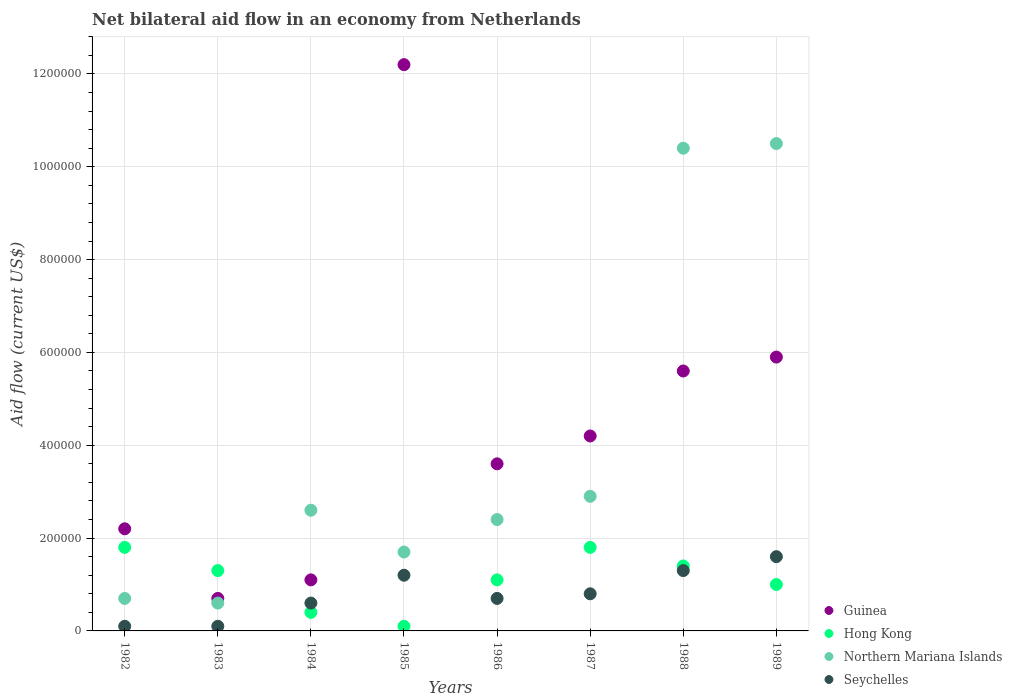Is the number of dotlines equal to the number of legend labels?
Your answer should be compact. Yes. What is the net bilateral aid flow in Northern Mariana Islands in 1987?
Make the answer very short. 2.90e+05. In which year was the net bilateral aid flow in Northern Mariana Islands minimum?
Your answer should be compact. 1983. What is the total net bilateral aid flow in Seychelles in the graph?
Offer a terse response. 6.40e+05. What is the difference between the net bilateral aid flow in Hong Kong in 1983 and that in 1987?
Your answer should be very brief. -5.00e+04. What is the average net bilateral aid flow in Northern Mariana Islands per year?
Offer a terse response. 3.98e+05. In the year 1985, what is the difference between the net bilateral aid flow in Hong Kong and net bilateral aid flow in Northern Mariana Islands?
Offer a terse response. -1.60e+05. What is the ratio of the net bilateral aid flow in Guinea in 1984 to that in 1985?
Keep it short and to the point. 0.09. Is the net bilateral aid flow in Guinea in 1982 less than that in 1983?
Your answer should be compact. No. Is the difference between the net bilateral aid flow in Hong Kong in 1982 and 1984 greater than the difference between the net bilateral aid flow in Northern Mariana Islands in 1982 and 1984?
Give a very brief answer. Yes. What is the difference between the highest and the second highest net bilateral aid flow in Hong Kong?
Offer a very short reply. 0. What is the difference between the highest and the lowest net bilateral aid flow in Guinea?
Provide a short and direct response. 1.15e+06. Is it the case that in every year, the sum of the net bilateral aid flow in Seychelles and net bilateral aid flow in Northern Mariana Islands  is greater than the sum of net bilateral aid flow in Guinea and net bilateral aid flow in Hong Kong?
Provide a short and direct response. No. Is it the case that in every year, the sum of the net bilateral aid flow in Hong Kong and net bilateral aid flow in Seychelles  is greater than the net bilateral aid flow in Guinea?
Provide a short and direct response. No. How many years are there in the graph?
Keep it short and to the point. 8. Are the values on the major ticks of Y-axis written in scientific E-notation?
Keep it short and to the point. No. Does the graph contain any zero values?
Offer a terse response. No. Where does the legend appear in the graph?
Give a very brief answer. Bottom right. How many legend labels are there?
Offer a very short reply. 4. How are the legend labels stacked?
Your response must be concise. Vertical. What is the title of the graph?
Give a very brief answer. Net bilateral aid flow in an economy from Netherlands. Does "New Caledonia" appear as one of the legend labels in the graph?
Offer a terse response. No. What is the label or title of the X-axis?
Ensure brevity in your answer.  Years. What is the Aid flow (current US$) of Guinea in 1982?
Offer a terse response. 2.20e+05. What is the Aid flow (current US$) in Northern Mariana Islands in 1982?
Offer a very short reply. 7.00e+04. What is the Aid flow (current US$) of Seychelles in 1982?
Keep it short and to the point. 10000. What is the Aid flow (current US$) in Guinea in 1983?
Your answer should be very brief. 7.00e+04. What is the Aid flow (current US$) of Guinea in 1984?
Make the answer very short. 1.10e+05. What is the Aid flow (current US$) in Hong Kong in 1984?
Offer a terse response. 4.00e+04. What is the Aid flow (current US$) in Seychelles in 1984?
Keep it short and to the point. 6.00e+04. What is the Aid flow (current US$) in Guinea in 1985?
Ensure brevity in your answer.  1.22e+06. What is the Aid flow (current US$) of Northern Mariana Islands in 1985?
Your answer should be compact. 1.70e+05. What is the Aid flow (current US$) in Guinea in 1986?
Offer a terse response. 3.60e+05. What is the Aid flow (current US$) of Hong Kong in 1986?
Keep it short and to the point. 1.10e+05. What is the Aid flow (current US$) in Northern Mariana Islands in 1986?
Your answer should be very brief. 2.40e+05. What is the Aid flow (current US$) in Hong Kong in 1987?
Your answer should be compact. 1.80e+05. What is the Aid flow (current US$) of Guinea in 1988?
Your response must be concise. 5.60e+05. What is the Aid flow (current US$) of Northern Mariana Islands in 1988?
Provide a succinct answer. 1.04e+06. What is the Aid flow (current US$) of Seychelles in 1988?
Your answer should be compact. 1.30e+05. What is the Aid flow (current US$) of Guinea in 1989?
Provide a succinct answer. 5.90e+05. What is the Aid flow (current US$) in Northern Mariana Islands in 1989?
Give a very brief answer. 1.05e+06. Across all years, what is the maximum Aid flow (current US$) in Guinea?
Your response must be concise. 1.22e+06. Across all years, what is the maximum Aid flow (current US$) in Northern Mariana Islands?
Your answer should be compact. 1.05e+06. Across all years, what is the maximum Aid flow (current US$) of Seychelles?
Your answer should be compact. 1.60e+05. Across all years, what is the minimum Aid flow (current US$) of Guinea?
Your answer should be very brief. 7.00e+04. Across all years, what is the minimum Aid flow (current US$) of Hong Kong?
Provide a succinct answer. 10000. Across all years, what is the minimum Aid flow (current US$) of Northern Mariana Islands?
Keep it short and to the point. 6.00e+04. What is the total Aid flow (current US$) in Guinea in the graph?
Offer a very short reply. 3.55e+06. What is the total Aid flow (current US$) in Hong Kong in the graph?
Keep it short and to the point. 8.90e+05. What is the total Aid flow (current US$) of Northern Mariana Islands in the graph?
Your answer should be compact. 3.18e+06. What is the total Aid flow (current US$) in Seychelles in the graph?
Your response must be concise. 6.40e+05. What is the difference between the Aid flow (current US$) of Hong Kong in 1982 and that in 1983?
Offer a very short reply. 5.00e+04. What is the difference between the Aid flow (current US$) in Seychelles in 1982 and that in 1983?
Keep it short and to the point. 0. What is the difference between the Aid flow (current US$) in Guinea in 1982 and that in 1984?
Your response must be concise. 1.10e+05. What is the difference between the Aid flow (current US$) of Hong Kong in 1982 and that in 1984?
Your answer should be compact. 1.40e+05. What is the difference between the Aid flow (current US$) in Seychelles in 1982 and that in 1984?
Provide a succinct answer. -5.00e+04. What is the difference between the Aid flow (current US$) in Northern Mariana Islands in 1982 and that in 1985?
Make the answer very short. -1.00e+05. What is the difference between the Aid flow (current US$) of Northern Mariana Islands in 1982 and that in 1986?
Provide a succinct answer. -1.70e+05. What is the difference between the Aid flow (current US$) in Hong Kong in 1982 and that in 1987?
Offer a very short reply. 0. What is the difference between the Aid flow (current US$) of Northern Mariana Islands in 1982 and that in 1987?
Your answer should be very brief. -2.20e+05. What is the difference between the Aid flow (current US$) of Hong Kong in 1982 and that in 1988?
Provide a short and direct response. 4.00e+04. What is the difference between the Aid flow (current US$) in Northern Mariana Islands in 1982 and that in 1988?
Give a very brief answer. -9.70e+05. What is the difference between the Aid flow (current US$) in Guinea in 1982 and that in 1989?
Make the answer very short. -3.70e+05. What is the difference between the Aid flow (current US$) in Northern Mariana Islands in 1982 and that in 1989?
Give a very brief answer. -9.80e+05. What is the difference between the Aid flow (current US$) in Seychelles in 1982 and that in 1989?
Ensure brevity in your answer.  -1.50e+05. What is the difference between the Aid flow (current US$) of Northern Mariana Islands in 1983 and that in 1984?
Your answer should be very brief. -2.00e+05. What is the difference between the Aid flow (current US$) in Seychelles in 1983 and that in 1984?
Offer a very short reply. -5.00e+04. What is the difference between the Aid flow (current US$) of Guinea in 1983 and that in 1985?
Offer a terse response. -1.15e+06. What is the difference between the Aid flow (current US$) in Hong Kong in 1983 and that in 1985?
Make the answer very short. 1.20e+05. What is the difference between the Aid flow (current US$) in Seychelles in 1983 and that in 1985?
Provide a succinct answer. -1.10e+05. What is the difference between the Aid flow (current US$) in Guinea in 1983 and that in 1987?
Provide a succinct answer. -3.50e+05. What is the difference between the Aid flow (current US$) in Guinea in 1983 and that in 1988?
Offer a terse response. -4.90e+05. What is the difference between the Aid flow (current US$) of Hong Kong in 1983 and that in 1988?
Make the answer very short. -10000. What is the difference between the Aid flow (current US$) of Northern Mariana Islands in 1983 and that in 1988?
Give a very brief answer. -9.80e+05. What is the difference between the Aid flow (current US$) in Seychelles in 1983 and that in 1988?
Your response must be concise. -1.20e+05. What is the difference between the Aid flow (current US$) in Guinea in 1983 and that in 1989?
Your response must be concise. -5.20e+05. What is the difference between the Aid flow (current US$) of Hong Kong in 1983 and that in 1989?
Provide a succinct answer. 3.00e+04. What is the difference between the Aid flow (current US$) of Northern Mariana Islands in 1983 and that in 1989?
Keep it short and to the point. -9.90e+05. What is the difference between the Aid flow (current US$) of Guinea in 1984 and that in 1985?
Make the answer very short. -1.11e+06. What is the difference between the Aid flow (current US$) in Hong Kong in 1984 and that in 1985?
Ensure brevity in your answer.  3.00e+04. What is the difference between the Aid flow (current US$) of Northern Mariana Islands in 1984 and that in 1985?
Offer a very short reply. 9.00e+04. What is the difference between the Aid flow (current US$) of Seychelles in 1984 and that in 1985?
Provide a short and direct response. -6.00e+04. What is the difference between the Aid flow (current US$) of Guinea in 1984 and that in 1987?
Provide a short and direct response. -3.10e+05. What is the difference between the Aid flow (current US$) of Northern Mariana Islands in 1984 and that in 1987?
Offer a very short reply. -3.00e+04. What is the difference between the Aid flow (current US$) of Seychelles in 1984 and that in 1987?
Provide a succinct answer. -2.00e+04. What is the difference between the Aid flow (current US$) of Guinea in 1984 and that in 1988?
Give a very brief answer. -4.50e+05. What is the difference between the Aid flow (current US$) of Northern Mariana Islands in 1984 and that in 1988?
Your response must be concise. -7.80e+05. What is the difference between the Aid flow (current US$) of Seychelles in 1984 and that in 1988?
Ensure brevity in your answer.  -7.00e+04. What is the difference between the Aid flow (current US$) of Guinea in 1984 and that in 1989?
Offer a very short reply. -4.80e+05. What is the difference between the Aid flow (current US$) in Northern Mariana Islands in 1984 and that in 1989?
Provide a short and direct response. -7.90e+05. What is the difference between the Aid flow (current US$) in Seychelles in 1984 and that in 1989?
Ensure brevity in your answer.  -1.00e+05. What is the difference between the Aid flow (current US$) of Guinea in 1985 and that in 1986?
Give a very brief answer. 8.60e+05. What is the difference between the Aid flow (current US$) in Hong Kong in 1985 and that in 1986?
Your answer should be compact. -1.00e+05. What is the difference between the Aid flow (current US$) in Hong Kong in 1985 and that in 1987?
Offer a very short reply. -1.70e+05. What is the difference between the Aid flow (current US$) of Seychelles in 1985 and that in 1987?
Offer a very short reply. 4.00e+04. What is the difference between the Aid flow (current US$) of Northern Mariana Islands in 1985 and that in 1988?
Offer a very short reply. -8.70e+05. What is the difference between the Aid flow (current US$) of Seychelles in 1985 and that in 1988?
Offer a very short reply. -10000. What is the difference between the Aid flow (current US$) in Guinea in 1985 and that in 1989?
Make the answer very short. 6.30e+05. What is the difference between the Aid flow (current US$) of Northern Mariana Islands in 1985 and that in 1989?
Keep it short and to the point. -8.80e+05. What is the difference between the Aid flow (current US$) of Hong Kong in 1986 and that in 1987?
Offer a terse response. -7.00e+04. What is the difference between the Aid flow (current US$) of Northern Mariana Islands in 1986 and that in 1987?
Offer a very short reply. -5.00e+04. What is the difference between the Aid flow (current US$) of Northern Mariana Islands in 1986 and that in 1988?
Offer a terse response. -8.00e+05. What is the difference between the Aid flow (current US$) in Guinea in 1986 and that in 1989?
Your answer should be very brief. -2.30e+05. What is the difference between the Aid flow (current US$) in Northern Mariana Islands in 1986 and that in 1989?
Give a very brief answer. -8.10e+05. What is the difference between the Aid flow (current US$) of Guinea in 1987 and that in 1988?
Keep it short and to the point. -1.40e+05. What is the difference between the Aid flow (current US$) in Hong Kong in 1987 and that in 1988?
Ensure brevity in your answer.  4.00e+04. What is the difference between the Aid flow (current US$) in Northern Mariana Islands in 1987 and that in 1988?
Provide a short and direct response. -7.50e+05. What is the difference between the Aid flow (current US$) in Guinea in 1987 and that in 1989?
Provide a succinct answer. -1.70e+05. What is the difference between the Aid flow (current US$) in Hong Kong in 1987 and that in 1989?
Your response must be concise. 8.00e+04. What is the difference between the Aid flow (current US$) in Northern Mariana Islands in 1987 and that in 1989?
Keep it short and to the point. -7.60e+05. What is the difference between the Aid flow (current US$) of Hong Kong in 1988 and that in 1989?
Your response must be concise. 4.00e+04. What is the difference between the Aid flow (current US$) of Northern Mariana Islands in 1988 and that in 1989?
Give a very brief answer. -10000. What is the difference between the Aid flow (current US$) in Seychelles in 1988 and that in 1989?
Your response must be concise. -3.00e+04. What is the difference between the Aid flow (current US$) of Guinea in 1982 and the Aid flow (current US$) of Hong Kong in 1983?
Offer a terse response. 9.00e+04. What is the difference between the Aid flow (current US$) in Guinea in 1982 and the Aid flow (current US$) in Northern Mariana Islands in 1983?
Make the answer very short. 1.60e+05. What is the difference between the Aid flow (current US$) of Hong Kong in 1982 and the Aid flow (current US$) of Seychelles in 1983?
Ensure brevity in your answer.  1.70e+05. What is the difference between the Aid flow (current US$) of Northern Mariana Islands in 1982 and the Aid flow (current US$) of Seychelles in 1983?
Provide a succinct answer. 6.00e+04. What is the difference between the Aid flow (current US$) in Guinea in 1982 and the Aid flow (current US$) in Hong Kong in 1984?
Offer a very short reply. 1.80e+05. What is the difference between the Aid flow (current US$) of Northern Mariana Islands in 1982 and the Aid flow (current US$) of Seychelles in 1984?
Your answer should be very brief. 10000. What is the difference between the Aid flow (current US$) of Guinea in 1982 and the Aid flow (current US$) of Hong Kong in 1985?
Your response must be concise. 2.10e+05. What is the difference between the Aid flow (current US$) in Guinea in 1982 and the Aid flow (current US$) in Northern Mariana Islands in 1985?
Make the answer very short. 5.00e+04. What is the difference between the Aid flow (current US$) of Hong Kong in 1982 and the Aid flow (current US$) of Seychelles in 1985?
Your answer should be compact. 6.00e+04. What is the difference between the Aid flow (current US$) of Northern Mariana Islands in 1982 and the Aid flow (current US$) of Seychelles in 1985?
Your response must be concise. -5.00e+04. What is the difference between the Aid flow (current US$) in Guinea in 1982 and the Aid flow (current US$) in Hong Kong in 1986?
Offer a terse response. 1.10e+05. What is the difference between the Aid flow (current US$) in Guinea in 1982 and the Aid flow (current US$) in Seychelles in 1986?
Offer a very short reply. 1.50e+05. What is the difference between the Aid flow (current US$) of Hong Kong in 1982 and the Aid flow (current US$) of Seychelles in 1986?
Offer a very short reply. 1.10e+05. What is the difference between the Aid flow (current US$) of Northern Mariana Islands in 1982 and the Aid flow (current US$) of Seychelles in 1986?
Your response must be concise. 0. What is the difference between the Aid flow (current US$) in Guinea in 1982 and the Aid flow (current US$) in Hong Kong in 1988?
Give a very brief answer. 8.00e+04. What is the difference between the Aid flow (current US$) in Guinea in 1982 and the Aid flow (current US$) in Northern Mariana Islands in 1988?
Ensure brevity in your answer.  -8.20e+05. What is the difference between the Aid flow (current US$) in Hong Kong in 1982 and the Aid flow (current US$) in Northern Mariana Islands in 1988?
Offer a very short reply. -8.60e+05. What is the difference between the Aid flow (current US$) of Northern Mariana Islands in 1982 and the Aid flow (current US$) of Seychelles in 1988?
Keep it short and to the point. -6.00e+04. What is the difference between the Aid flow (current US$) of Guinea in 1982 and the Aid flow (current US$) of Northern Mariana Islands in 1989?
Give a very brief answer. -8.30e+05. What is the difference between the Aid flow (current US$) of Guinea in 1982 and the Aid flow (current US$) of Seychelles in 1989?
Your answer should be compact. 6.00e+04. What is the difference between the Aid flow (current US$) of Hong Kong in 1982 and the Aid flow (current US$) of Northern Mariana Islands in 1989?
Provide a short and direct response. -8.70e+05. What is the difference between the Aid flow (current US$) in Hong Kong in 1982 and the Aid flow (current US$) in Seychelles in 1989?
Your answer should be very brief. 2.00e+04. What is the difference between the Aid flow (current US$) in Northern Mariana Islands in 1982 and the Aid flow (current US$) in Seychelles in 1989?
Your response must be concise. -9.00e+04. What is the difference between the Aid flow (current US$) in Guinea in 1983 and the Aid flow (current US$) in Hong Kong in 1984?
Your answer should be compact. 3.00e+04. What is the difference between the Aid flow (current US$) in Guinea in 1983 and the Aid flow (current US$) in Northern Mariana Islands in 1984?
Keep it short and to the point. -1.90e+05. What is the difference between the Aid flow (current US$) of Hong Kong in 1983 and the Aid flow (current US$) of Seychelles in 1984?
Provide a short and direct response. 7.00e+04. What is the difference between the Aid flow (current US$) in Northern Mariana Islands in 1983 and the Aid flow (current US$) in Seychelles in 1984?
Your response must be concise. 0. What is the difference between the Aid flow (current US$) of Guinea in 1983 and the Aid flow (current US$) of Seychelles in 1985?
Provide a short and direct response. -5.00e+04. What is the difference between the Aid flow (current US$) in Guinea in 1983 and the Aid flow (current US$) in Northern Mariana Islands in 1986?
Your response must be concise. -1.70e+05. What is the difference between the Aid flow (current US$) in Guinea in 1983 and the Aid flow (current US$) in Seychelles in 1986?
Provide a short and direct response. 0. What is the difference between the Aid flow (current US$) of Northern Mariana Islands in 1983 and the Aid flow (current US$) of Seychelles in 1986?
Provide a succinct answer. -10000. What is the difference between the Aid flow (current US$) of Guinea in 1983 and the Aid flow (current US$) of Hong Kong in 1987?
Your answer should be compact. -1.10e+05. What is the difference between the Aid flow (current US$) of Guinea in 1983 and the Aid flow (current US$) of Northern Mariana Islands in 1987?
Make the answer very short. -2.20e+05. What is the difference between the Aid flow (current US$) of Hong Kong in 1983 and the Aid flow (current US$) of Seychelles in 1987?
Offer a very short reply. 5.00e+04. What is the difference between the Aid flow (current US$) of Guinea in 1983 and the Aid flow (current US$) of Hong Kong in 1988?
Give a very brief answer. -7.00e+04. What is the difference between the Aid flow (current US$) in Guinea in 1983 and the Aid flow (current US$) in Northern Mariana Islands in 1988?
Provide a short and direct response. -9.70e+05. What is the difference between the Aid flow (current US$) of Guinea in 1983 and the Aid flow (current US$) of Seychelles in 1988?
Keep it short and to the point. -6.00e+04. What is the difference between the Aid flow (current US$) of Hong Kong in 1983 and the Aid flow (current US$) of Northern Mariana Islands in 1988?
Give a very brief answer. -9.10e+05. What is the difference between the Aid flow (current US$) of Hong Kong in 1983 and the Aid flow (current US$) of Seychelles in 1988?
Your answer should be very brief. 0. What is the difference between the Aid flow (current US$) of Guinea in 1983 and the Aid flow (current US$) of Hong Kong in 1989?
Keep it short and to the point. -3.00e+04. What is the difference between the Aid flow (current US$) of Guinea in 1983 and the Aid flow (current US$) of Northern Mariana Islands in 1989?
Your answer should be very brief. -9.80e+05. What is the difference between the Aid flow (current US$) of Guinea in 1983 and the Aid flow (current US$) of Seychelles in 1989?
Keep it short and to the point. -9.00e+04. What is the difference between the Aid flow (current US$) in Hong Kong in 1983 and the Aid flow (current US$) in Northern Mariana Islands in 1989?
Make the answer very short. -9.20e+05. What is the difference between the Aid flow (current US$) in Northern Mariana Islands in 1983 and the Aid flow (current US$) in Seychelles in 1989?
Provide a short and direct response. -1.00e+05. What is the difference between the Aid flow (current US$) in Guinea in 1984 and the Aid flow (current US$) in Hong Kong in 1985?
Keep it short and to the point. 1.00e+05. What is the difference between the Aid flow (current US$) of Guinea in 1984 and the Aid flow (current US$) of Northern Mariana Islands in 1985?
Offer a very short reply. -6.00e+04. What is the difference between the Aid flow (current US$) of Guinea in 1984 and the Aid flow (current US$) of Seychelles in 1985?
Ensure brevity in your answer.  -10000. What is the difference between the Aid flow (current US$) of Hong Kong in 1984 and the Aid flow (current US$) of Northern Mariana Islands in 1985?
Offer a terse response. -1.30e+05. What is the difference between the Aid flow (current US$) in Hong Kong in 1984 and the Aid flow (current US$) in Seychelles in 1985?
Ensure brevity in your answer.  -8.00e+04. What is the difference between the Aid flow (current US$) in Guinea in 1984 and the Aid flow (current US$) in Seychelles in 1986?
Ensure brevity in your answer.  4.00e+04. What is the difference between the Aid flow (current US$) of Hong Kong in 1984 and the Aid flow (current US$) of Seychelles in 1986?
Provide a short and direct response. -3.00e+04. What is the difference between the Aid flow (current US$) in Northern Mariana Islands in 1984 and the Aid flow (current US$) in Seychelles in 1986?
Your answer should be very brief. 1.90e+05. What is the difference between the Aid flow (current US$) in Guinea in 1984 and the Aid flow (current US$) in Hong Kong in 1987?
Keep it short and to the point. -7.00e+04. What is the difference between the Aid flow (current US$) of Guinea in 1984 and the Aid flow (current US$) of Northern Mariana Islands in 1987?
Ensure brevity in your answer.  -1.80e+05. What is the difference between the Aid flow (current US$) in Guinea in 1984 and the Aid flow (current US$) in Seychelles in 1987?
Give a very brief answer. 3.00e+04. What is the difference between the Aid flow (current US$) of Hong Kong in 1984 and the Aid flow (current US$) of Northern Mariana Islands in 1987?
Provide a short and direct response. -2.50e+05. What is the difference between the Aid flow (current US$) of Hong Kong in 1984 and the Aid flow (current US$) of Seychelles in 1987?
Offer a very short reply. -4.00e+04. What is the difference between the Aid flow (current US$) of Guinea in 1984 and the Aid flow (current US$) of Hong Kong in 1988?
Your answer should be compact. -3.00e+04. What is the difference between the Aid flow (current US$) of Guinea in 1984 and the Aid flow (current US$) of Northern Mariana Islands in 1988?
Provide a short and direct response. -9.30e+05. What is the difference between the Aid flow (current US$) in Northern Mariana Islands in 1984 and the Aid flow (current US$) in Seychelles in 1988?
Your answer should be compact. 1.30e+05. What is the difference between the Aid flow (current US$) of Guinea in 1984 and the Aid flow (current US$) of Hong Kong in 1989?
Provide a succinct answer. 10000. What is the difference between the Aid flow (current US$) in Guinea in 1984 and the Aid flow (current US$) in Northern Mariana Islands in 1989?
Offer a terse response. -9.40e+05. What is the difference between the Aid flow (current US$) of Hong Kong in 1984 and the Aid flow (current US$) of Northern Mariana Islands in 1989?
Provide a short and direct response. -1.01e+06. What is the difference between the Aid flow (current US$) in Northern Mariana Islands in 1984 and the Aid flow (current US$) in Seychelles in 1989?
Your response must be concise. 1.00e+05. What is the difference between the Aid flow (current US$) in Guinea in 1985 and the Aid flow (current US$) in Hong Kong in 1986?
Provide a succinct answer. 1.11e+06. What is the difference between the Aid flow (current US$) of Guinea in 1985 and the Aid flow (current US$) of Northern Mariana Islands in 1986?
Provide a succinct answer. 9.80e+05. What is the difference between the Aid flow (current US$) of Guinea in 1985 and the Aid flow (current US$) of Seychelles in 1986?
Offer a terse response. 1.15e+06. What is the difference between the Aid flow (current US$) in Guinea in 1985 and the Aid flow (current US$) in Hong Kong in 1987?
Your answer should be very brief. 1.04e+06. What is the difference between the Aid flow (current US$) of Guinea in 1985 and the Aid flow (current US$) of Northern Mariana Islands in 1987?
Provide a short and direct response. 9.30e+05. What is the difference between the Aid flow (current US$) in Guinea in 1985 and the Aid flow (current US$) in Seychelles in 1987?
Keep it short and to the point. 1.14e+06. What is the difference between the Aid flow (current US$) of Hong Kong in 1985 and the Aid flow (current US$) of Northern Mariana Islands in 1987?
Ensure brevity in your answer.  -2.80e+05. What is the difference between the Aid flow (current US$) in Guinea in 1985 and the Aid flow (current US$) in Hong Kong in 1988?
Provide a short and direct response. 1.08e+06. What is the difference between the Aid flow (current US$) in Guinea in 1985 and the Aid flow (current US$) in Seychelles in 1988?
Your answer should be very brief. 1.09e+06. What is the difference between the Aid flow (current US$) of Hong Kong in 1985 and the Aid flow (current US$) of Northern Mariana Islands in 1988?
Provide a short and direct response. -1.03e+06. What is the difference between the Aid flow (current US$) of Guinea in 1985 and the Aid flow (current US$) of Hong Kong in 1989?
Offer a very short reply. 1.12e+06. What is the difference between the Aid flow (current US$) of Guinea in 1985 and the Aid flow (current US$) of Seychelles in 1989?
Offer a terse response. 1.06e+06. What is the difference between the Aid flow (current US$) in Hong Kong in 1985 and the Aid flow (current US$) in Northern Mariana Islands in 1989?
Offer a very short reply. -1.04e+06. What is the difference between the Aid flow (current US$) in Hong Kong in 1985 and the Aid flow (current US$) in Seychelles in 1989?
Your response must be concise. -1.50e+05. What is the difference between the Aid flow (current US$) in Guinea in 1986 and the Aid flow (current US$) in Hong Kong in 1987?
Ensure brevity in your answer.  1.80e+05. What is the difference between the Aid flow (current US$) in Guinea in 1986 and the Aid flow (current US$) in Northern Mariana Islands in 1987?
Offer a terse response. 7.00e+04. What is the difference between the Aid flow (current US$) of Guinea in 1986 and the Aid flow (current US$) of Seychelles in 1987?
Keep it short and to the point. 2.80e+05. What is the difference between the Aid flow (current US$) in Northern Mariana Islands in 1986 and the Aid flow (current US$) in Seychelles in 1987?
Offer a very short reply. 1.60e+05. What is the difference between the Aid flow (current US$) in Guinea in 1986 and the Aid flow (current US$) in Hong Kong in 1988?
Give a very brief answer. 2.20e+05. What is the difference between the Aid flow (current US$) of Guinea in 1986 and the Aid flow (current US$) of Northern Mariana Islands in 1988?
Ensure brevity in your answer.  -6.80e+05. What is the difference between the Aid flow (current US$) in Hong Kong in 1986 and the Aid flow (current US$) in Northern Mariana Islands in 1988?
Make the answer very short. -9.30e+05. What is the difference between the Aid flow (current US$) of Hong Kong in 1986 and the Aid flow (current US$) of Seychelles in 1988?
Provide a short and direct response. -2.00e+04. What is the difference between the Aid flow (current US$) in Guinea in 1986 and the Aid flow (current US$) in Northern Mariana Islands in 1989?
Ensure brevity in your answer.  -6.90e+05. What is the difference between the Aid flow (current US$) in Hong Kong in 1986 and the Aid flow (current US$) in Northern Mariana Islands in 1989?
Give a very brief answer. -9.40e+05. What is the difference between the Aid flow (current US$) of Hong Kong in 1986 and the Aid flow (current US$) of Seychelles in 1989?
Give a very brief answer. -5.00e+04. What is the difference between the Aid flow (current US$) of Northern Mariana Islands in 1986 and the Aid flow (current US$) of Seychelles in 1989?
Ensure brevity in your answer.  8.00e+04. What is the difference between the Aid flow (current US$) of Guinea in 1987 and the Aid flow (current US$) of Northern Mariana Islands in 1988?
Provide a succinct answer. -6.20e+05. What is the difference between the Aid flow (current US$) in Guinea in 1987 and the Aid flow (current US$) in Seychelles in 1988?
Keep it short and to the point. 2.90e+05. What is the difference between the Aid flow (current US$) of Hong Kong in 1987 and the Aid flow (current US$) of Northern Mariana Islands in 1988?
Give a very brief answer. -8.60e+05. What is the difference between the Aid flow (current US$) of Northern Mariana Islands in 1987 and the Aid flow (current US$) of Seychelles in 1988?
Provide a succinct answer. 1.60e+05. What is the difference between the Aid flow (current US$) in Guinea in 1987 and the Aid flow (current US$) in Hong Kong in 1989?
Provide a short and direct response. 3.20e+05. What is the difference between the Aid flow (current US$) in Guinea in 1987 and the Aid flow (current US$) in Northern Mariana Islands in 1989?
Offer a very short reply. -6.30e+05. What is the difference between the Aid flow (current US$) of Hong Kong in 1987 and the Aid flow (current US$) of Northern Mariana Islands in 1989?
Provide a short and direct response. -8.70e+05. What is the difference between the Aid flow (current US$) in Northern Mariana Islands in 1987 and the Aid flow (current US$) in Seychelles in 1989?
Make the answer very short. 1.30e+05. What is the difference between the Aid flow (current US$) of Guinea in 1988 and the Aid flow (current US$) of Northern Mariana Islands in 1989?
Your response must be concise. -4.90e+05. What is the difference between the Aid flow (current US$) in Guinea in 1988 and the Aid flow (current US$) in Seychelles in 1989?
Ensure brevity in your answer.  4.00e+05. What is the difference between the Aid flow (current US$) in Hong Kong in 1988 and the Aid flow (current US$) in Northern Mariana Islands in 1989?
Your response must be concise. -9.10e+05. What is the difference between the Aid flow (current US$) of Northern Mariana Islands in 1988 and the Aid flow (current US$) of Seychelles in 1989?
Ensure brevity in your answer.  8.80e+05. What is the average Aid flow (current US$) of Guinea per year?
Make the answer very short. 4.44e+05. What is the average Aid flow (current US$) of Hong Kong per year?
Make the answer very short. 1.11e+05. What is the average Aid flow (current US$) of Northern Mariana Islands per year?
Offer a terse response. 3.98e+05. What is the average Aid flow (current US$) in Seychelles per year?
Provide a short and direct response. 8.00e+04. In the year 1982, what is the difference between the Aid flow (current US$) in Guinea and Aid flow (current US$) in Hong Kong?
Keep it short and to the point. 4.00e+04. In the year 1982, what is the difference between the Aid flow (current US$) of Guinea and Aid flow (current US$) of Seychelles?
Give a very brief answer. 2.10e+05. In the year 1982, what is the difference between the Aid flow (current US$) of Hong Kong and Aid flow (current US$) of Seychelles?
Keep it short and to the point. 1.70e+05. In the year 1983, what is the difference between the Aid flow (current US$) of Guinea and Aid flow (current US$) of Hong Kong?
Provide a succinct answer. -6.00e+04. In the year 1983, what is the difference between the Aid flow (current US$) in Guinea and Aid flow (current US$) in Northern Mariana Islands?
Your answer should be very brief. 10000. In the year 1983, what is the difference between the Aid flow (current US$) in Guinea and Aid flow (current US$) in Seychelles?
Your response must be concise. 6.00e+04. In the year 1983, what is the difference between the Aid flow (current US$) in Northern Mariana Islands and Aid flow (current US$) in Seychelles?
Provide a short and direct response. 5.00e+04. In the year 1984, what is the difference between the Aid flow (current US$) in Guinea and Aid flow (current US$) in Northern Mariana Islands?
Offer a very short reply. -1.50e+05. In the year 1984, what is the difference between the Aid flow (current US$) of Guinea and Aid flow (current US$) of Seychelles?
Ensure brevity in your answer.  5.00e+04. In the year 1984, what is the difference between the Aid flow (current US$) of Northern Mariana Islands and Aid flow (current US$) of Seychelles?
Give a very brief answer. 2.00e+05. In the year 1985, what is the difference between the Aid flow (current US$) of Guinea and Aid flow (current US$) of Hong Kong?
Your answer should be very brief. 1.21e+06. In the year 1985, what is the difference between the Aid flow (current US$) in Guinea and Aid flow (current US$) in Northern Mariana Islands?
Offer a terse response. 1.05e+06. In the year 1985, what is the difference between the Aid flow (current US$) in Guinea and Aid flow (current US$) in Seychelles?
Offer a very short reply. 1.10e+06. In the year 1985, what is the difference between the Aid flow (current US$) in Hong Kong and Aid flow (current US$) in Seychelles?
Ensure brevity in your answer.  -1.10e+05. In the year 1986, what is the difference between the Aid flow (current US$) in Guinea and Aid flow (current US$) in Seychelles?
Offer a very short reply. 2.90e+05. In the year 1986, what is the difference between the Aid flow (current US$) in Hong Kong and Aid flow (current US$) in Seychelles?
Provide a succinct answer. 4.00e+04. In the year 1986, what is the difference between the Aid flow (current US$) in Northern Mariana Islands and Aid flow (current US$) in Seychelles?
Make the answer very short. 1.70e+05. In the year 1987, what is the difference between the Aid flow (current US$) in Guinea and Aid flow (current US$) in Hong Kong?
Your answer should be compact. 2.40e+05. In the year 1987, what is the difference between the Aid flow (current US$) of Guinea and Aid flow (current US$) of Northern Mariana Islands?
Your answer should be very brief. 1.30e+05. In the year 1987, what is the difference between the Aid flow (current US$) in Hong Kong and Aid flow (current US$) in Seychelles?
Offer a very short reply. 1.00e+05. In the year 1987, what is the difference between the Aid flow (current US$) of Northern Mariana Islands and Aid flow (current US$) of Seychelles?
Provide a short and direct response. 2.10e+05. In the year 1988, what is the difference between the Aid flow (current US$) in Guinea and Aid flow (current US$) in Northern Mariana Islands?
Make the answer very short. -4.80e+05. In the year 1988, what is the difference between the Aid flow (current US$) of Guinea and Aid flow (current US$) of Seychelles?
Keep it short and to the point. 4.30e+05. In the year 1988, what is the difference between the Aid flow (current US$) in Hong Kong and Aid flow (current US$) in Northern Mariana Islands?
Provide a short and direct response. -9.00e+05. In the year 1988, what is the difference between the Aid flow (current US$) of Hong Kong and Aid flow (current US$) of Seychelles?
Your response must be concise. 10000. In the year 1988, what is the difference between the Aid flow (current US$) of Northern Mariana Islands and Aid flow (current US$) of Seychelles?
Your answer should be compact. 9.10e+05. In the year 1989, what is the difference between the Aid flow (current US$) of Guinea and Aid flow (current US$) of Hong Kong?
Your answer should be very brief. 4.90e+05. In the year 1989, what is the difference between the Aid flow (current US$) in Guinea and Aid flow (current US$) in Northern Mariana Islands?
Make the answer very short. -4.60e+05. In the year 1989, what is the difference between the Aid flow (current US$) of Guinea and Aid flow (current US$) of Seychelles?
Your answer should be compact. 4.30e+05. In the year 1989, what is the difference between the Aid flow (current US$) in Hong Kong and Aid flow (current US$) in Northern Mariana Islands?
Your answer should be compact. -9.50e+05. In the year 1989, what is the difference between the Aid flow (current US$) of Hong Kong and Aid flow (current US$) of Seychelles?
Offer a very short reply. -6.00e+04. In the year 1989, what is the difference between the Aid flow (current US$) in Northern Mariana Islands and Aid flow (current US$) in Seychelles?
Give a very brief answer. 8.90e+05. What is the ratio of the Aid flow (current US$) in Guinea in 1982 to that in 1983?
Provide a succinct answer. 3.14. What is the ratio of the Aid flow (current US$) in Hong Kong in 1982 to that in 1983?
Provide a short and direct response. 1.38. What is the ratio of the Aid flow (current US$) in Seychelles in 1982 to that in 1983?
Provide a short and direct response. 1. What is the ratio of the Aid flow (current US$) of Guinea in 1982 to that in 1984?
Your response must be concise. 2. What is the ratio of the Aid flow (current US$) of Northern Mariana Islands in 1982 to that in 1984?
Keep it short and to the point. 0.27. What is the ratio of the Aid flow (current US$) in Seychelles in 1982 to that in 1984?
Your answer should be very brief. 0.17. What is the ratio of the Aid flow (current US$) in Guinea in 1982 to that in 1985?
Make the answer very short. 0.18. What is the ratio of the Aid flow (current US$) in Hong Kong in 1982 to that in 1985?
Provide a succinct answer. 18. What is the ratio of the Aid flow (current US$) in Northern Mariana Islands in 1982 to that in 1985?
Your response must be concise. 0.41. What is the ratio of the Aid flow (current US$) in Seychelles in 1982 to that in 1985?
Offer a very short reply. 0.08. What is the ratio of the Aid flow (current US$) of Guinea in 1982 to that in 1986?
Provide a succinct answer. 0.61. What is the ratio of the Aid flow (current US$) of Hong Kong in 1982 to that in 1986?
Provide a short and direct response. 1.64. What is the ratio of the Aid flow (current US$) of Northern Mariana Islands in 1982 to that in 1986?
Your answer should be very brief. 0.29. What is the ratio of the Aid flow (current US$) in Seychelles in 1982 to that in 1986?
Provide a succinct answer. 0.14. What is the ratio of the Aid flow (current US$) in Guinea in 1982 to that in 1987?
Offer a terse response. 0.52. What is the ratio of the Aid flow (current US$) of Hong Kong in 1982 to that in 1987?
Your answer should be compact. 1. What is the ratio of the Aid flow (current US$) in Northern Mariana Islands in 1982 to that in 1987?
Give a very brief answer. 0.24. What is the ratio of the Aid flow (current US$) of Guinea in 1982 to that in 1988?
Offer a terse response. 0.39. What is the ratio of the Aid flow (current US$) in Northern Mariana Islands in 1982 to that in 1988?
Make the answer very short. 0.07. What is the ratio of the Aid flow (current US$) in Seychelles in 1982 to that in 1988?
Provide a short and direct response. 0.08. What is the ratio of the Aid flow (current US$) in Guinea in 1982 to that in 1989?
Provide a succinct answer. 0.37. What is the ratio of the Aid flow (current US$) in Northern Mariana Islands in 1982 to that in 1989?
Keep it short and to the point. 0.07. What is the ratio of the Aid flow (current US$) in Seychelles in 1982 to that in 1989?
Ensure brevity in your answer.  0.06. What is the ratio of the Aid flow (current US$) in Guinea in 1983 to that in 1984?
Offer a very short reply. 0.64. What is the ratio of the Aid flow (current US$) of Northern Mariana Islands in 1983 to that in 1984?
Your answer should be compact. 0.23. What is the ratio of the Aid flow (current US$) in Seychelles in 1983 to that in 1984?
Keep it short and to the point. 0.17. What is the ratio of the Aid flow (current US$) in Guinea in 1983 to that in 1985?
Offer a very short reply. 0.06. What is the ratio of the Aid flow (current US$) of Hong Kong in 1983 to that in 1985?
Offer a terse response. 13. What is the ratio of the Aid flow (current US$) of Northern Mariana Islands in 1983 to that in 1985?
Ensure brevity in your answer.  0.35. What is the ratio of the Aid flow (current US$) of Seychelles in 1983 to that in 1985?
Your answer should be very brief. 0.08. What is the ratio of the Aid flow (current US$) of Guinea in 1983 to that in 1986?
Your response must be concise. 0.19. What is the ratio of the Aid flow (current US$) in Hong Kong in 1983 to that in 1986?
Keep it short and to the point. 1.18. What is the ratio of the Aid flow (current US$) of Northern Mariana Islands in 1983 to that in 1986?
Offer a terse response. 0.25. What is the ratio of the Aid flow (current US$) of Seychelles in 1983 to that in 1986?
Provide a short and direct response. 0.14. What is the ratio of the Aid flow (current US$) in Guinea in 1983 to that in 1987?
Provide a short and direct response. 0.17. What is the ratio of the Aid flow (current US$) of Hong Kong in 1983 to that in 1987?
Your answer should be very brief. 0.72. What is the ratio of the Aid flow (current US$) of Northern Mariana Islands in 1983 to that in 1987?
Provide a succinct answer. 0.21. What is the ratio of the Aid flow (current US$) of Seychelles in 1983 to that in 1987?
Give a very brief answer. 0.12. What is the ratio of the Aid flow (current US$) of Guinea in 1983 to that in 1988?
Offer a very short reply. 0.12. What is the ratio of the Aid flow (current US$) of Hong Kong in 1983 to that in 1988?
Your response must be concise. 0.93. What is the ratio of the Aid flow (current US$) of Northern Mariana Islands in 1983 to that in 1988?
Provide a short and direct response. 0.06. What is the ratio of the Aid flow (current US$) in Seychelles in 1983 to that in 1988?
Your answer should be compact. 0.08. What is the ratio of the Aid flow (current US$) of Guinea in 1983 to that in 1989?
Give a very brief answer. 0.12. What is the ratio of the Aid flow (current US$) in Northern Mariana Islands in 1983 to that in 1989?
Make the answer very short. 0.06. What is the ratio of the Aid flow (current US$) of Seychelles in 1983 to that in 1989?
Ensure brevity in your answer.  0.06. What is the ratio of the Aid flow (current US$) in Guinea in 1984 to that in 1985?
Provide a short and direct response. 0.09. What is the ratio of the Aid flow (current US$) of Hong Kong in 1984 to that in 1985?
Give a very brief answer. 4. What is the ratio of the Aid flow (current US$) in Northern Mariana Islands in 1984 to that in 1985?
Offer a very short reply. 1.53. What is the ratio of the Aid flow (current US$) of Guinea in 1984 to that in 1986?
Provide a short and direct response. 0.31. What is the ratio of the Aid flow (current US$) of Hong Kong in 1984 to that in 1986?
Provide a short and direct response. 0.36. What is the ratio of the Aid flow (current US$) of Seychelles in 1984 to that in 1986?
Your answer should be very brief. 0.86. What is the ratio of the Aid flow (current US$) in Guinea in 1984 to that in 1987?
Your answer should be very brief. 0.26. What is the ratio of the Aid flow (current US$) in Hong Kong in 1984 to that in 1987?
Offer a terse response. 0.22. What is the ratio of the Aid flow (current US$) of Northern Mariana Islands in 1984 to that in 1987?
Give a very brief answer. 0.9. What is the ratio of the Aid flow (current US$) in Seychelles in 1984 to that in 1987?
Your response must be concise. 0.75. What is the ratio of the Aid flow (current US$) in Guinea in 1984 to that in 1988?
Offer a very short reply. 0.2. What is the ratio of the Aid flow (current US$) in Hong Kong in 1984 to that in 1988?
Your answer should be compact. 0.29. What is the ratio of the Aid flow (current US$) in Seychelles in 1984 to that in 1988?
Provide a succinct answer. 0.46. What is the ratio of the Aid flow (current US$) in Guinea in 1984 to that in 1989?
Your answer should be compact. 0.19. What is the ratio of the Aid flow (current US$) in Hong Kong in 1984 to that in 1989?
Your answer should be very brief. 0.4. What is the ratio of the Aid flow (current US$) in Northern Mariana Islands in 1984 to that in 1989?
Offer a terse response. 0.25. What is the ratio of the Aid flow (current US$) in Seychelles in 1984 to that in 1989?
Your answer should be compact. 0.38. What is the ratio of the Aid flow (current US$) in Guinea in 1985 to that in 1986?
Provide a short and direct response. 3.39. What is the ratio of the Aid flow (current US$) in Hong Kong in 1985 to that in 1986?
Provide a succinct answer. 0.09. What is the ratio of the Aid flow (current US$) in Northern Mariana Islands in 1985 to that in 1986?
Provide a succinct answer. 0.71. What is the ratio of the Aid flow (current US$) in Seychelles in 1985 to that in 1986?
Offer a very short reply. 1.71. What is the ratio of the Aid flow (current US$) in Guinea in 1985 to that in 1987?
Your response must be concise. 2.9. What is the ratio of the Aid flow (current US$) of Hong Kong in 1985 to that in 1987?
Keep it short and to the point. 0.06. What is the ratio of the Aid flow (current US$) of Northern Mariana Islands in 1985 to that in 1987?
Provide a succinct answer. 0.59. What is the ratio of the Aid flow (current US$) of Guinea in 1985 to that in 1988?
Keep it short and to the point. 2.18. What is the ratio of the Aid flow (current US$) in Hong Kong in 1985 to that in 1988?
Give a very brief answer. 0.07. What is the ratio of the Aid flow (current US$) in Northern Mariana Islands in 1985 to that in 1988?
Provide a succinct answer. 0.16. What is the ratio of the Aid flow (current US$) in Seychelles in 1985 to that in 1988?
Offer a very short reply. 0.92. What is the ratio of the Aid flow (current US$) of Guinea in 1985 to that in 1989?
Your response must be concise. 2.07. What is the ratio of the Aid flow (current US$) in Northern Mariana Islands in 1985 to that in 1989?
Make the answer very short. 0.16. What is the ratio of the Aid flow (current US$) of Seychelles in 1985 to that in 1989?
Your answer should be very brief. 0.75. What is the ratio of the Aid flow (current US$) of Guinea in 1986 to that in 1987?
Give a very brief answer. 0.86. What is the ratio of the Aid flow (current US$) of Hong Kong in 1986 to that in 1987?
Your answer should be compact. 0.61. What is the ratio of the Aid flow (current US$) in Northern Mariana Islands in 1986 to that in 1987?
Keep it short and to the point. 0.83. What is the ratio of the Aid flow (current US$) of Guinea in 1986 to that in 1988?
Provide a succinct answer. 0.64. What is the ratio of the Aid flow (current US$) in Hong Kong in 1986 to that in 1988?
Ensure brevity in your answer.  0.79. What is the ratio of the Aid flow (current US$) in Northern Mariana Islands in 1986 to that in 1988?
Your answer should be very brief. 0.23. What is the ratio of the Aid flow (current US$) in Seychelles in 1986 to that in 1988?
Your answer should be compact. 0.54. What is the ratio of the Aid flow (current US$) in Guinea in 1986 to that in 1989?
Offer a terse response. 0.61. What is the ratio of the Aid flow (current US$) of Hong Kong in 1986 to that in 1989?
Ensure brevity in your answer.  1.1. What is the ratio of the Aid flow (current US$) in Northern Mariana Islands in 1986 to that in 1989?
Your answer should be very brief. 0.23. What is the ratio of the Aid flow (current US$) of Seychelles in 1986 to that in 1989?
Ensure brevity in your answer.  0.44. What is the ratio of the Aid flow (current US$) in Northern Mariana Islands in 1987 to that in 1988?
Provide a short and direct response. 0.28. What is the ratio of the Aid flow (current US$) of Seychelles in 1987 to that in 1988?
Give a very brief answer. 0.62. What is the ratio of the Aid flow (current US$) of Guinea in 1987 to that in 1989?
Ensure brevity in your answer.  0.71. What is the ratio of the Aid flow (current US$) of Hong Kong in 1987 to that in 1989?
Offer a terse response. 1.8. What is the ratio of the Aid flow (current US$) of Northern Mariana Islands in 1987 to that in 1989?
Give a very brief answer. 0.28. What is the ratio of the Aid flow (current US$) in Seychelles in 1987 to that in 1989?
Keep it short and to the point. 0.5. What is the ratio of the Aid flow (current US$) of Guinea in 1988 to that in 1989?
Your answer should be compact. 0.95. What is the ratio of the Aid flow (current US$) in Hong Kong in 1988 to that in 1989?
Offer a terse response. 1.4. What is the ratio of the Aid flow (current US$) in Seychelles in 1988 to that in 1989?
Give a very brief answer. 0.81. What is the difference between the highest and the second highest Aid flow (current US$) in Guinea?
Your answer should be very brief. 6.30e+05. What is the difference between the highest and the second highest Aid flow (current US$) of Hong Kong?
Provide a succinct answer. 0. What is the difference between the highest and the second highest Aid flow (current US$) in Northern Mariana Islands?
Provide a succinct answer. 10000. What is the difference between the highest and the lowest Aid flow (current US$) in Guinea?
Your response must be concise. 1.15e+06. What is the difference between the highest and the lowest Aid flow (current US$) in Hong Kong?
Offer a very short reply. 1.70e+05. What is the difference between the highest and the lowest Aid flow (current US$) in Northern Mariana Islands?
Give a very brief answer. 9.90e+05. 